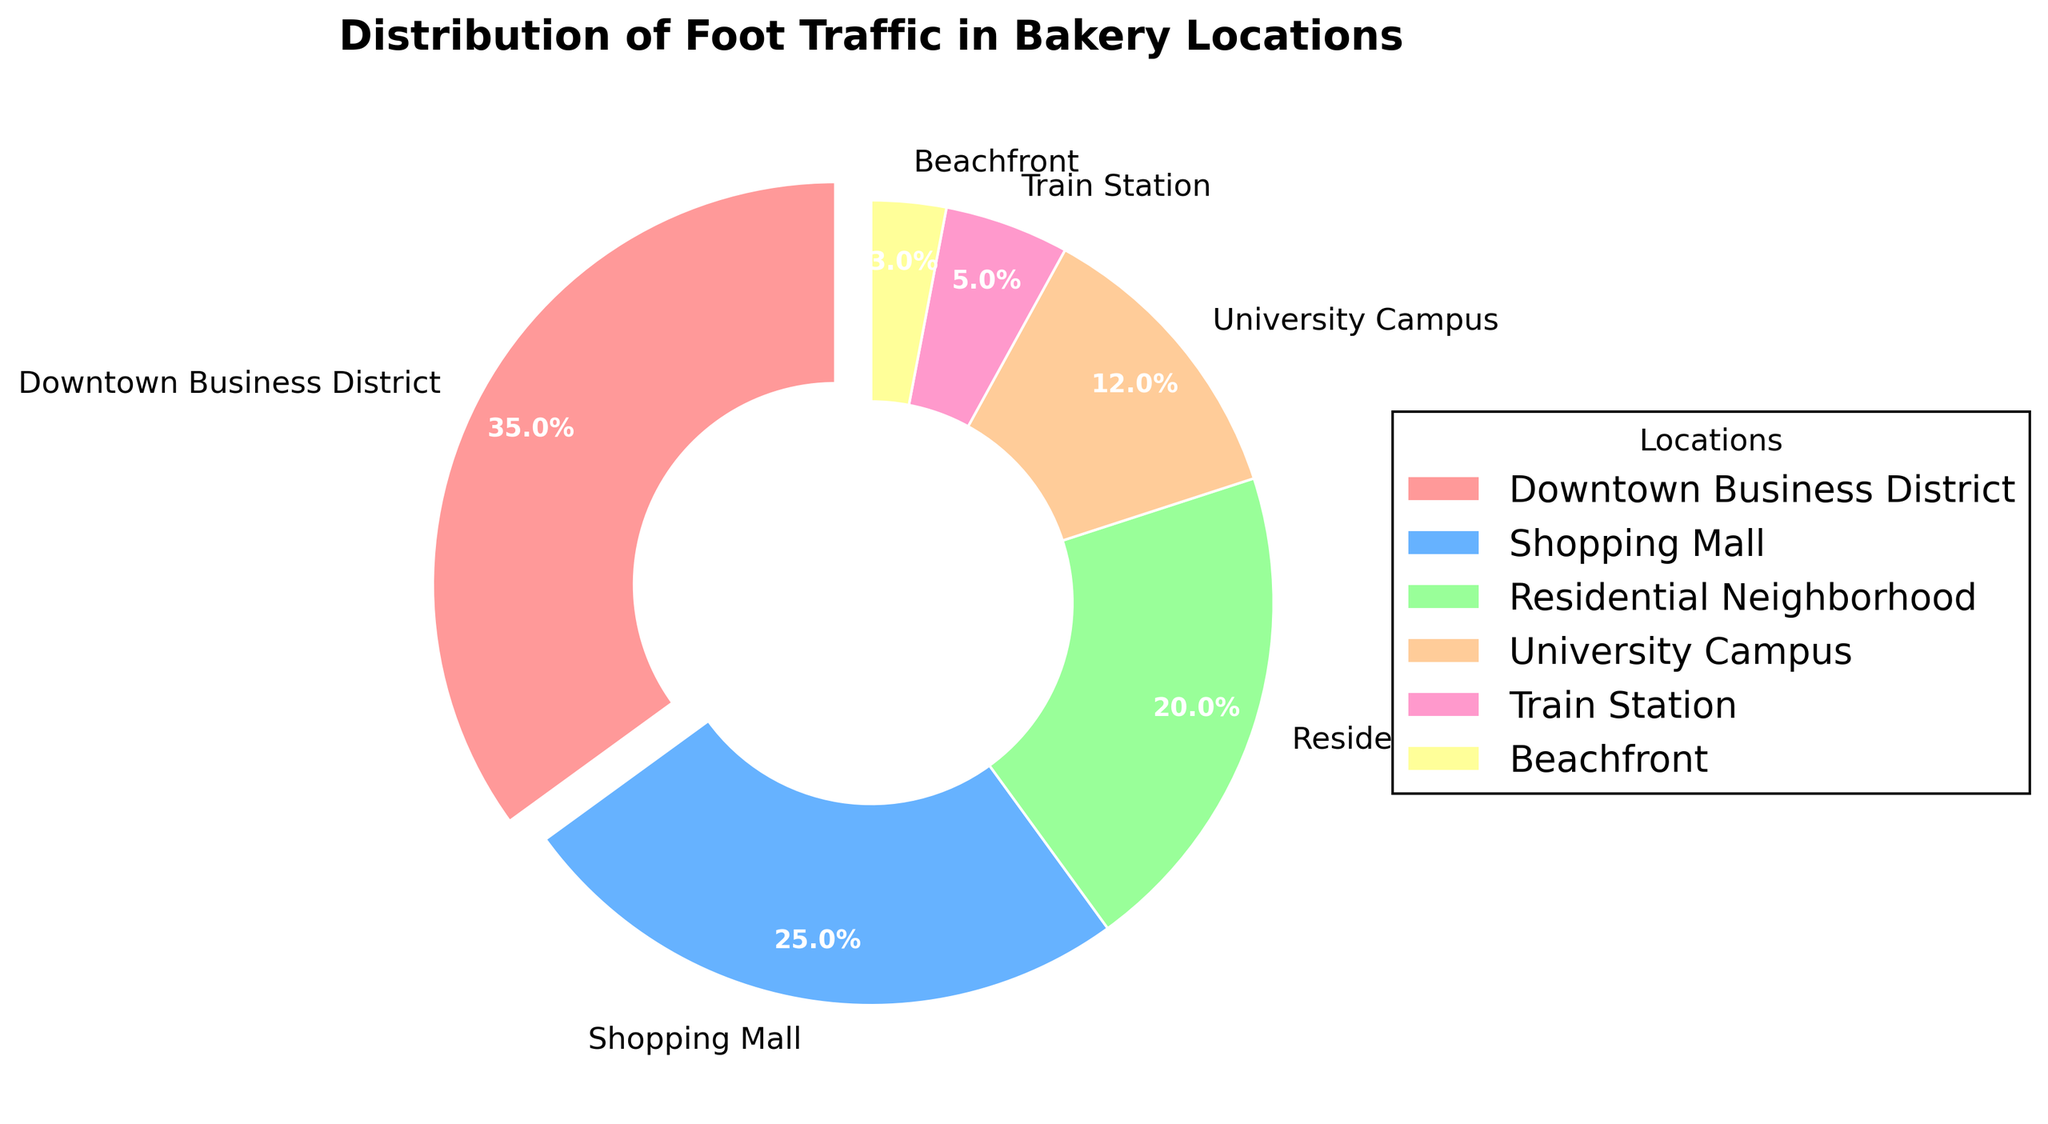Which location has the highest foot traffic? The wedge representing the Downtown Business District is the largest segment, encompassing 35% of the pie chart. This indicates that the Downtown Business District has the highest foot traffic.
Answer: Downtown Business District Which location has the lowest foot traffic, and what is its percentage? The smallest segment of the pie chart corresponds to the Beachfront, which accounts for 3% of the foot traffic.
Answer: Beachfront, 3% What is the total foot traffic in the University Campus and Train Station locations combined? The University Campus accounts for 12% and the Train Station for 5%. Adding these percentages together gives us 12% + 5% = 17%.
Answer: 17% How does the foot traffic in the Shopping Mall compare to the Downtown Business District? The Shopping Mall has 25% foot traffic, while the Downtown Business District has 35%. The Downtown Business District has a higher foot traffic percentage compared to the Shopping Mall.
Answer: The Downtown Business District has higher foot traffic Which location has foot traffic that is closer to the Residential Neighborhood? Residential Neighborhood has 20% foot traffic. The closest foot traffic percentage is the University Campus with 12%. However, none of the locations are very close, making University Campus the nearest percentage.
Answer: University Campus What is the cumulative foot traffic for the Downtown Business District, Shopping Mall, and Residential Neighborhood? The Downtown Business District is 35%, Shopping Mall is 25%, and Residential Neighborhood is 20%. Summing them gives 35% + 25% + 20% = 80%.
Answer: 80% Compare the foot traffic in the Train Station and Beachfront locations. The Train Station has 5% foot traffic while the Beachfront has 3%. The Train Station has higher foot traffic compared to the Beachfront.
Answer: Train Station has higher foot traffic If you were to redistribute 2% foot traffic from the Downtown Business District to the Beachfront, what would their new percentages be? The Downtown Business District originally has 35%, and Beachfront has 3%. Redistributing 2% means Downtown Business District would reduce to 35% - 2% = 33%, and Beachfront would increase to 3% + 2% = 5%.
Answer: Downtown Business District: 33%, Beachfront: 5% 